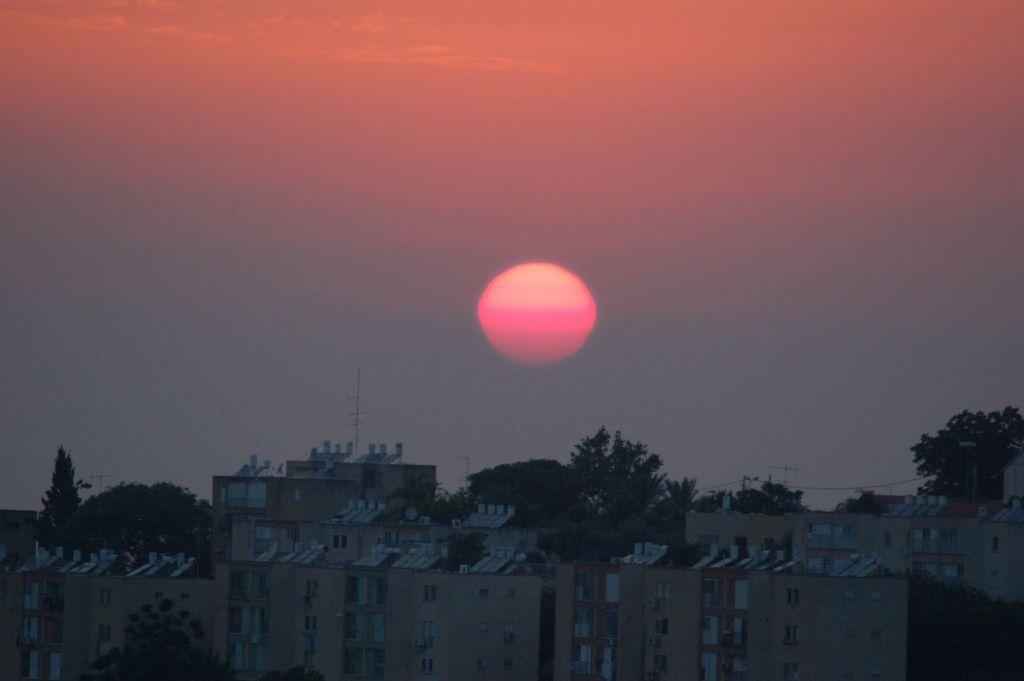What type of structures can be seen in the image? There are buildings in the image. What other natural elements are present in the image? There are trees in the image. What feature do the buildings have? The buildings have windows. What time of day is depicted in the image? There is a sunset visible in the image. What type of mint is growing near the buildings in the image? There is no mint present in the image; it features buildings and trees. 